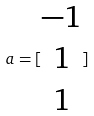Convert formula to latex. <formula><loc_0><loc_0><loc_500><loc_500>a = [ \begin{matrix} - 1 \\ 1 \\ 1 \end{matrix} ]</formula> 